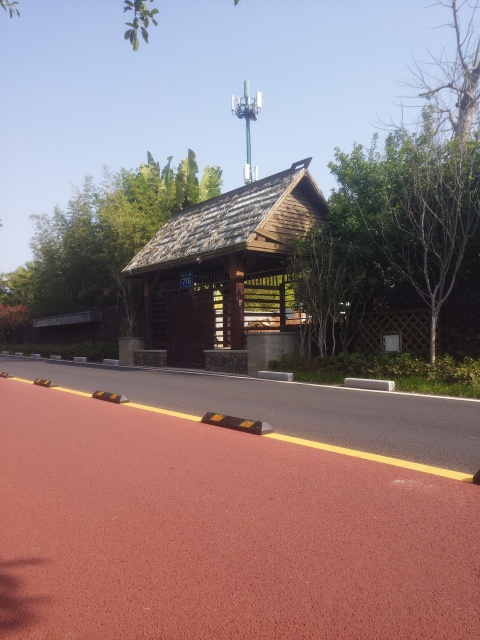What's the architectural style of the building in the image? The architectural style of the building appears to be reminiscent of a rustic or country-inspired design, featuring a sloped roof with wooden shingles and a structure largely made of timber, blending in with the natural surroundings. 